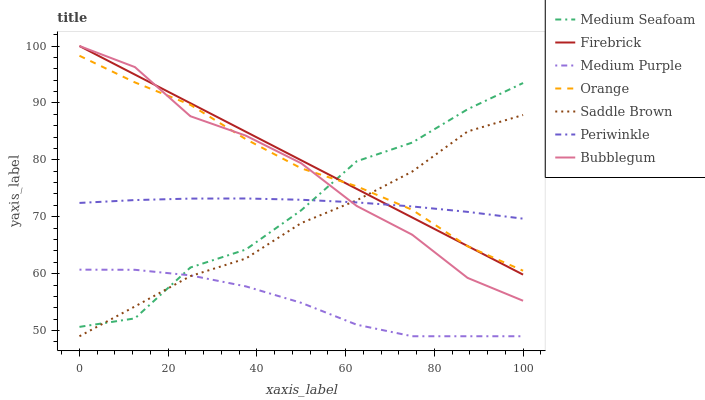Does Bubblegum have the minimum area under the curve?
Answer yes or no. No. Does Bubblegum have the maximum area under the curve?
Answer yes or no. No. Is Bubblegum the smoothest?
Answer yes or no. No. Is Bubblegum the roughest?
Answer yes or no. No. Does Bubblegum have the lowest value?
Answer yes or no. No. Does Saddle Brown have the highest value?
Answer yes or no. No. Is Medium Purple less than Periwinkle?
Answer yes or no. Yes. Is Firebrick greater than Medium Purple?
Answer yes or no. Yes. Does Medium Purple intersect Periwinkle?
Answer yes or no. No. 